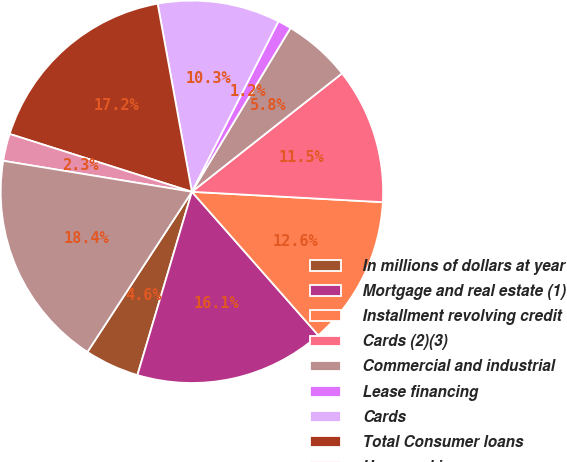Convert chart to OTSL. <chart><loc_0><loc_0><loc_500><loc_500><pie_chart><fcel>In millions of dollars at year<fcel>Mortgage and real estate (1)<fcel>Installment revolving credit<fcel>Cards (2)(3)<fcel>Commercial and industrial<fcel>Lease financing<fcel>Cards<fcel>Total Consumer loans<fcel>Unearned income<fcel>Consumer loans net of unearned<nl><fcel>4.6%<fcel>16.09%<fcel>12.64%<fcel>11.49%<fcel>5.75%<fcel>1.15%<fcel>10.34%<fcel>17.24%<fcel>2.3%<fcel>18.39%<nl></chart> 